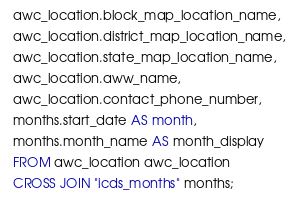Convert code to text. <code><loc_0><loc_0><loc_500><loc_500><_SQL_>  awc_location.block_map_location_name,
  awc_location.district_map_location_name,
  awc_location.state_map_location_name,
  awc_location.aww_name,
  awc_location.contact_phone_number,
  months.start_date AS month,
  months.month_name AS month_display
  FROM awc_location awc_location
  CROSS JOIN "icds_months" months;
</code> 